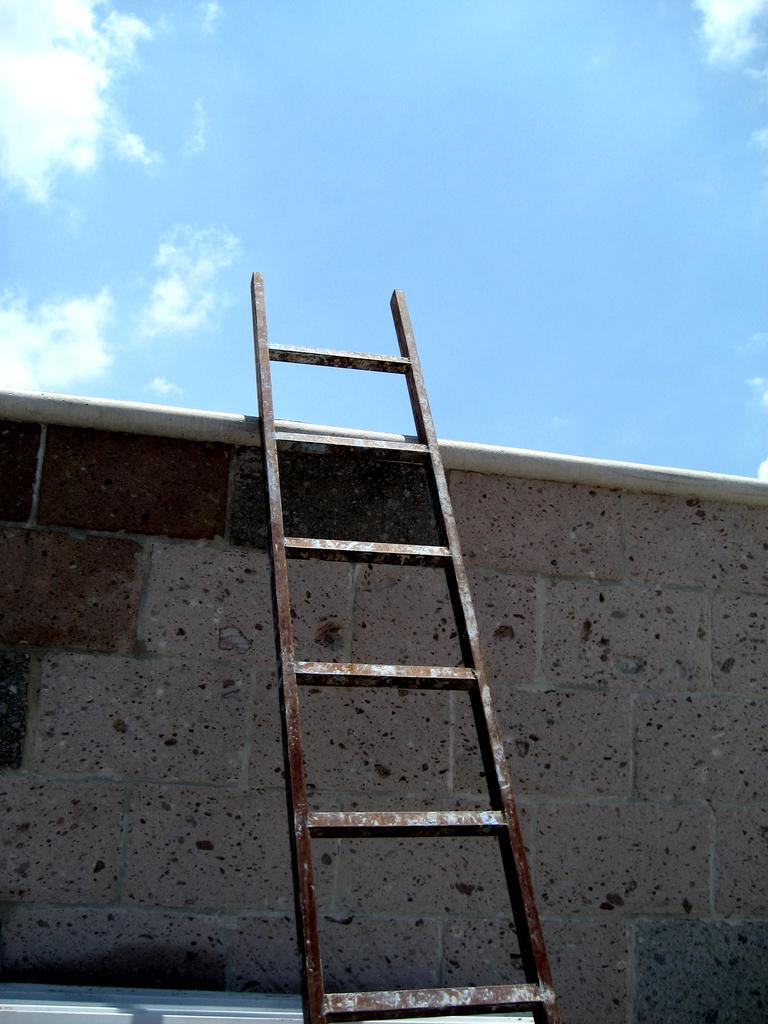What object is present in the image that can be used for climbing? There is a ladder in the image. What structure is visible in the image that the ladder might be leaning against? There is a wall in the image. What is visible at the top of the image? The sky is visible at the top of the image. What type of soda is being poured from the ladder in the image? There is no soda present in the image, and the ladder is not being used for pouring anything. What nut is being used to climb the wall in the image? There are no nuts present in the image, and the ladder is being used for climbing, not a nut. 